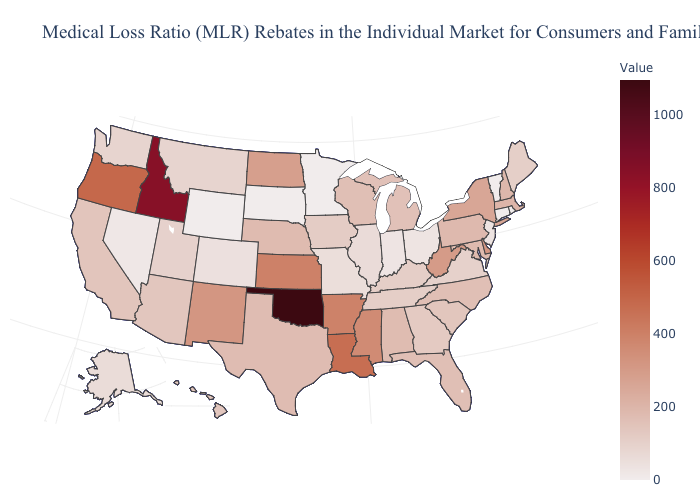Which states have the lowest value in the South?
Short answer required. Virginia. Which states have the lowest value in the South?
Quick response, please. Virginia. Among the states that border Idaho , which have the lowest value?
Concise answer only. Wyoming. Among the states that border New Hampshire , which have the lowest value?
Write a very short answer. Vermont. Which states have the lowest value in the USA?
Short answer required. Connecticut, Minnesota, Rhode Island, South Dakota, Vermont, Wyoming. 